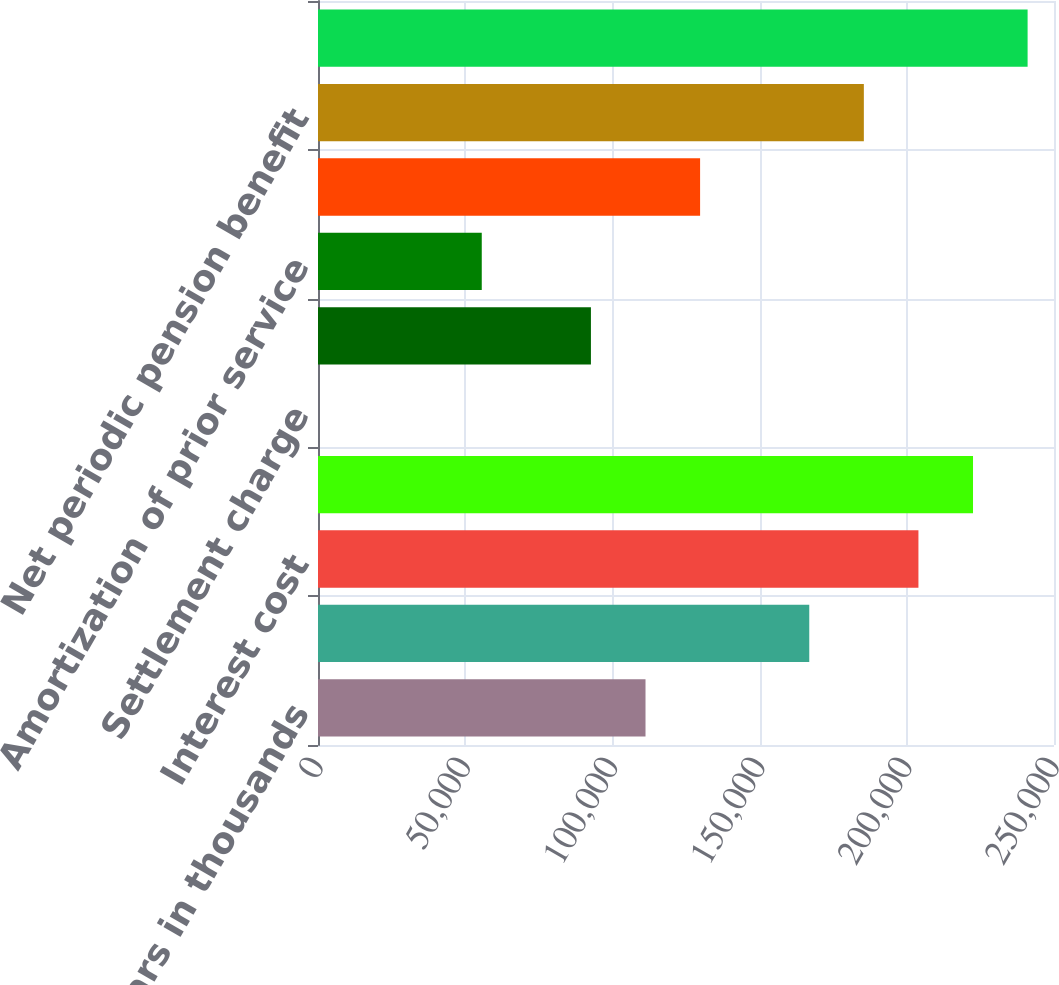<chart> <loc_0><loc_0><loc_500><loc_500><bar_chart><fcel>dollars in thousands<fcel>Service cost<fcel>Interest cost<fcel>Expected return on plan assets<fcel>Settlement charge<fcel>Curtailment loss<fcel>Amortization of prior service<fcel>Amortization of actuarial loss<fcel>Net periodic pension benefit<fcel>Net actuarial loss (gain)<nl><fcel>111248<fcel>166870<fcel>203952<fcel>222493<fcel>2.82<fcel>92706.9<fcel>55625.3<fcel>129789<fcel>185411<fcel>241033<nl></chart> 